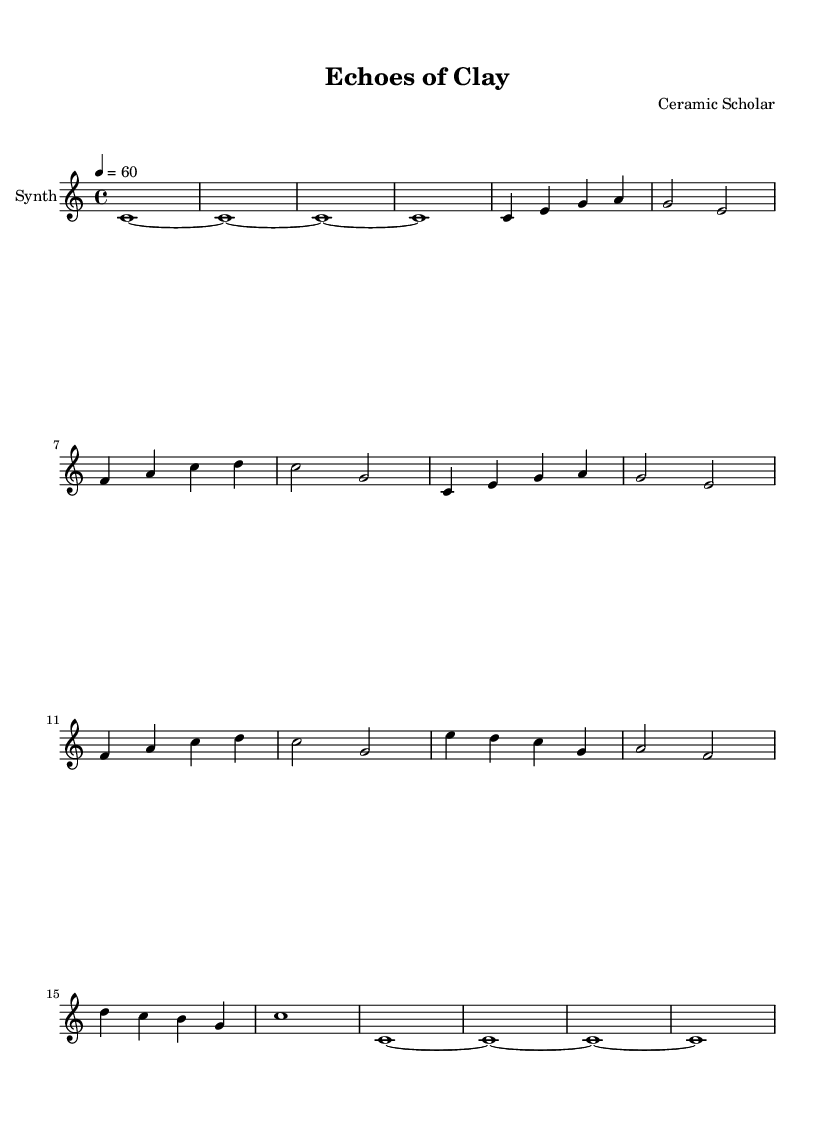What is the key signature of this music? The key signature is located at the beginning of the staff. In this case, it shows no sharps or flats, which indicates the key of C major.
Answer: C major What is the time signature of this piece? The time signature is displayed at the beginning of the music, showing that there are four beats in each measure, indicated by 4/4.
Answer: 4/4 What is the tempo marking of this piece? The tempo indication is found in the initial part of the sheet music, specifying that the piece should be played at a tempo of 60 beats per minute (4 = 60).
Answer: 60 How many measures are there in the main theme? The main theme comprises a set of musical phrases. Counting the measures from the start of the main theme to its end reveals that there are 8 measures total.
Answer: 8 What type of instrument is notated in the score? The instrument is identified at the beginning of the score, where it specifies that the music is for a synthesizer.
Answer: Synth What rhythmic pattern is echoed in the intro and outro? Both the intro and outro consist of a whole note pattern. The intro has four measures of whole notes, which is the same in the outro.
Answer: Whole notes Which section has a contrasting melodic line? Upon comparison of different sections, the bridge introduces a new set of melodic lines that distinctly differ from both the intro and main theme, creating contrast.
Answer: Bridge 